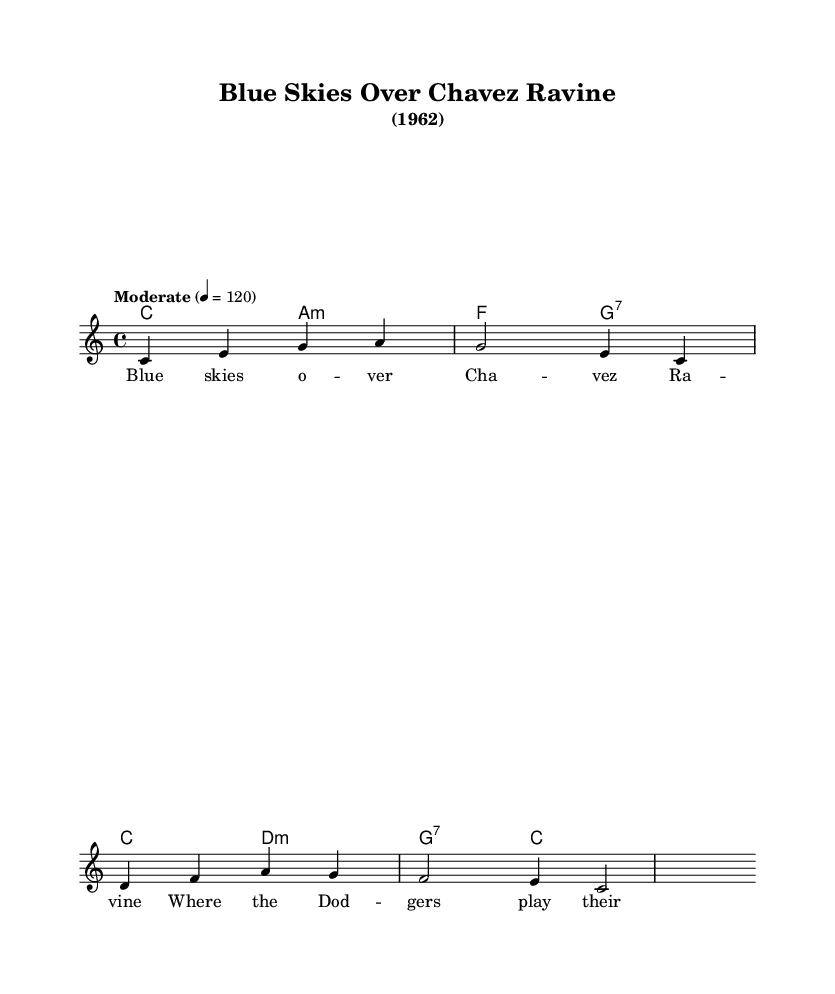What is the key signature of this music? The key signature is indicated at the beginning of the score, and it shows C major, which has no sharps or flats.
Answer: C major What is the time signature of this music? The time signature is found at the beginning of the score, which shows 4/4, meaning there are four beats per measure, and the quarter note gets one beat.
Answer: 4/4 What is the tempo marking of this music? The tempo marking is written above the staff, stating "Moderate" with a tempo of 4 beats per minute equals 120.
Answer: Moderate How many chords are there in the harmonies? By counting the chord symbols in the harmonies section, there are a total of four distinct chords that can be identified.
Answer: 4 What is the first lyric of the verse? The first lyric in the verse is found within the lyrics section, where "Blue skies" is the initial phrase.
Answer: Blue skies What type of song structure is evident in the score? The song structure can be inferred through the presence of verses and the notation used for melody and harmonies, indicating it's a popular music format with lyrics.
Answer: Verse Which bar contains a D minor chord? The D minor chord is located in the third bar of the harmonies section, indicated by the "d:m" chord symbol.
Answer: Third bar 